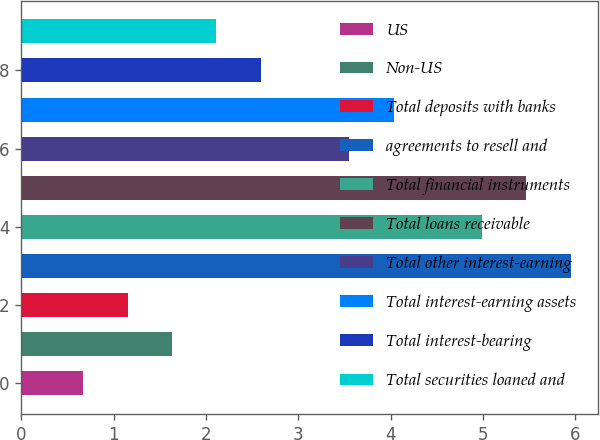<chart> <loc_0><loc_0><loc_500><loc_500><bar_chart><fcel>US<fcel>Non-US<fcel>Total deposits with banks<fcel>agreements to resell and<fcel>Total financial instruments<fcel>Total loans receivable<fcel>Total other interest-earning<fcel>Total interest-earning assets<fcel>Total interest-bearing<fcel>Total securities loaned and<nl><fcel>0.67<fcel>1.63<fcel>1.15<fcel>5.95<fcel>4.99<fcel>5.47<fcel>3.55<fcel>4.03<fcel>2.59<fcel>2.11<nl></chart> 